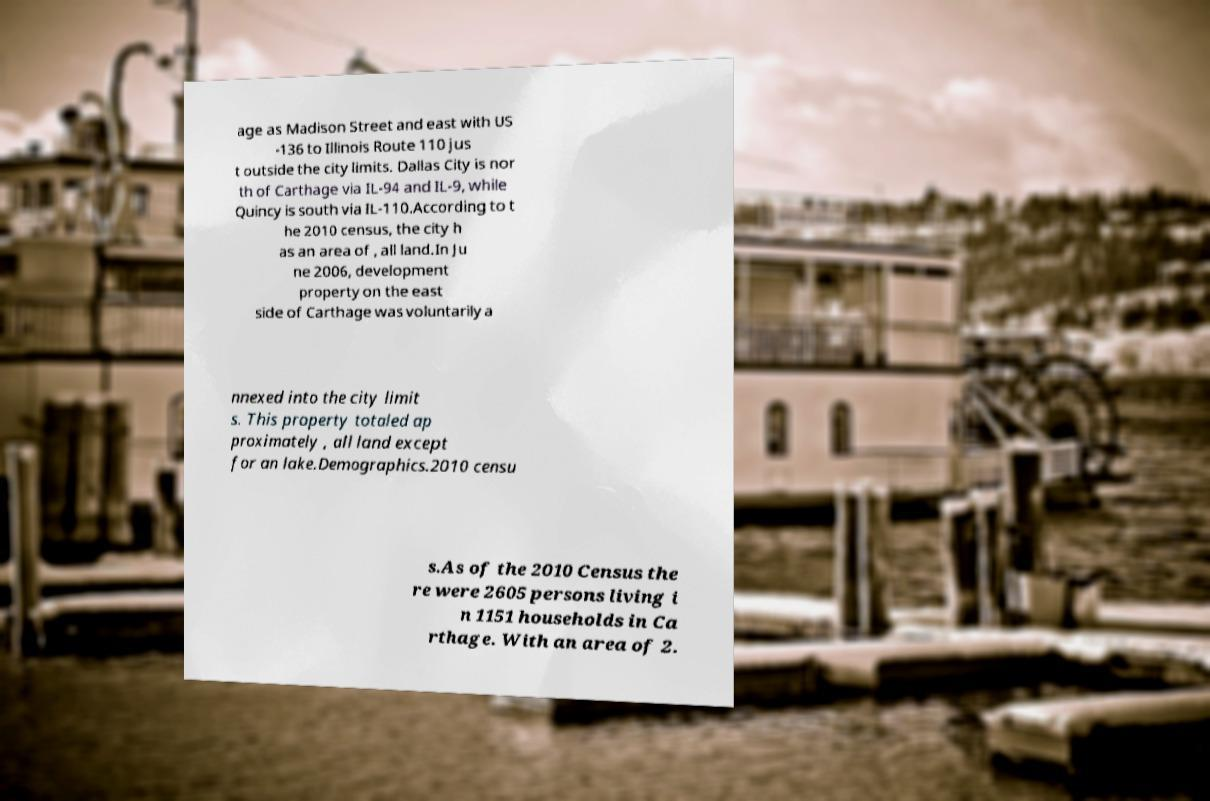There's text embedded in this image that I need extracted. Can you transcribe it verbatim? age as Madison Street and east with US -136 to Illinois Route 110 jus t outside the city limits. Dallas City is nor th of Carthage via IL-94 and IL-9, while Quincy is south via IL-110.According to t he 2010 census, the city h as an area of , all land.In Ju ne 2006, development property on the east side of Carthage was voluntarily a nnexed into the city limit s. This property totaled ap proximately , all land except for an lake.Demographics.2010 censu s.As of the 2010 Census the re were 2605 persons living i n 1151 households in Ca rthage. With an area of 2. 